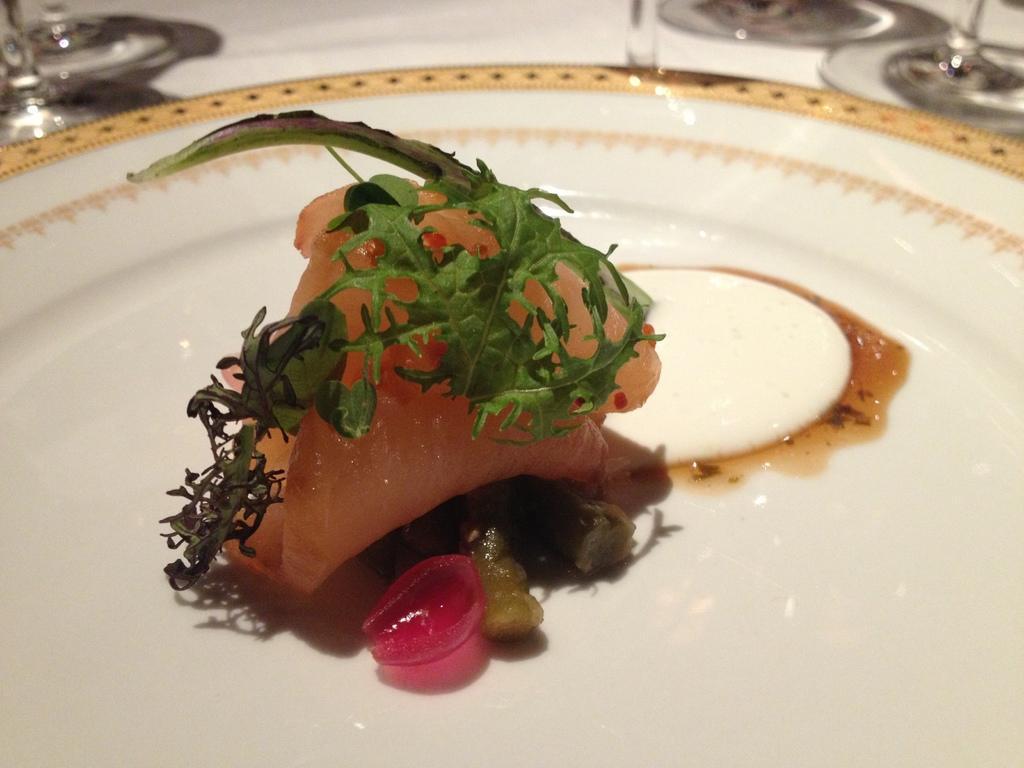Can you describe this image briefly? In this image, we can see a table, on that table, we can see a white colored cloth and a plate with some food. On the right side of the table, we can see some glasses. On the left side of the table, we can see few glasses. 